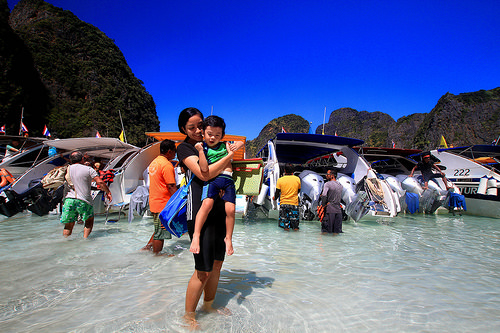<image>
Can you confirm if the girl is under the sky? Yes. The girl is positioned underneath the sky, with the sky above it in the vertical space. Where is the small child in relation to the young woman? Is it behind the young woman? No. The small child is not behind the young woman. From this viewpoint, the small child appears to be positioned elsewhere in the scene. 